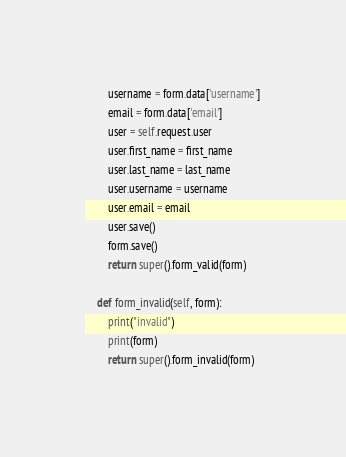Convert code to text. <code><loc_0><loc_0><loc_500><loc_500><_Python_>        username = form.data['username']
        email = form.data['email']
        user = self.request.user
        user.first_name = first_name
        user.last_name = last_name
        user.username = username
        user.email = email
        user.save()
        form.save()
        return super().form_valid(form)

    def form_invalid(self, form):
        print("invalid")
        print(form)
        return super().form_invalid(form)
</code> 